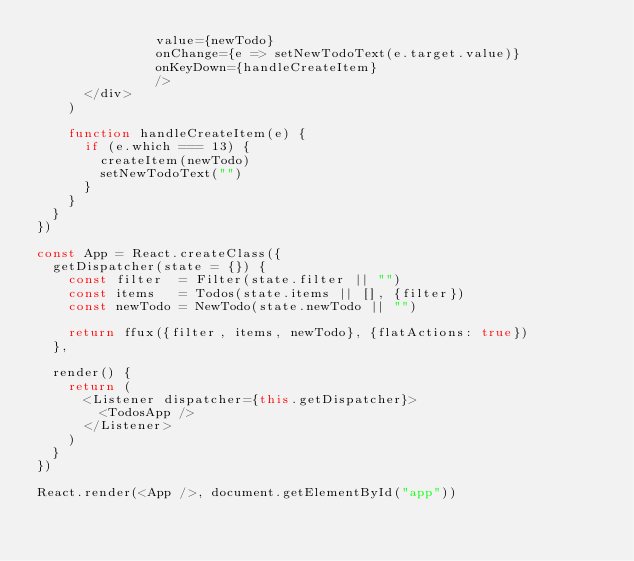<code> <loc_0><loc_0><loc_500><loc_500><_JavaScript_>               value={newTodo}
               onChange={e => setNewTodoText(e.target.value)}
               onKeyDown={handleCreateItem}
               />
      </div>
    )

    function handleCreateItem(e) {
      if (e.which === 13) {
        createItem(newTodo)
        setNewTodoText("")
      }
    }
  }
})

const App = React.createClass({
  getDispatcher(state = {}) {
    const filter  = Filter(state.filter || "")
    const items   = Todos(state.items || [], {filter})
    const newTodo = NewTodo(state.newTodo || "")

    return ffux({filter, items, newTodo}, {flatActions: true})
  },

  render() {
    return (
      <Listener dispatcher={this.getDispatcher}>
        <TodosApp />
      </Listener>
    )
  }
})

React.render(<App />, document.getElementById("app"))
</code> 